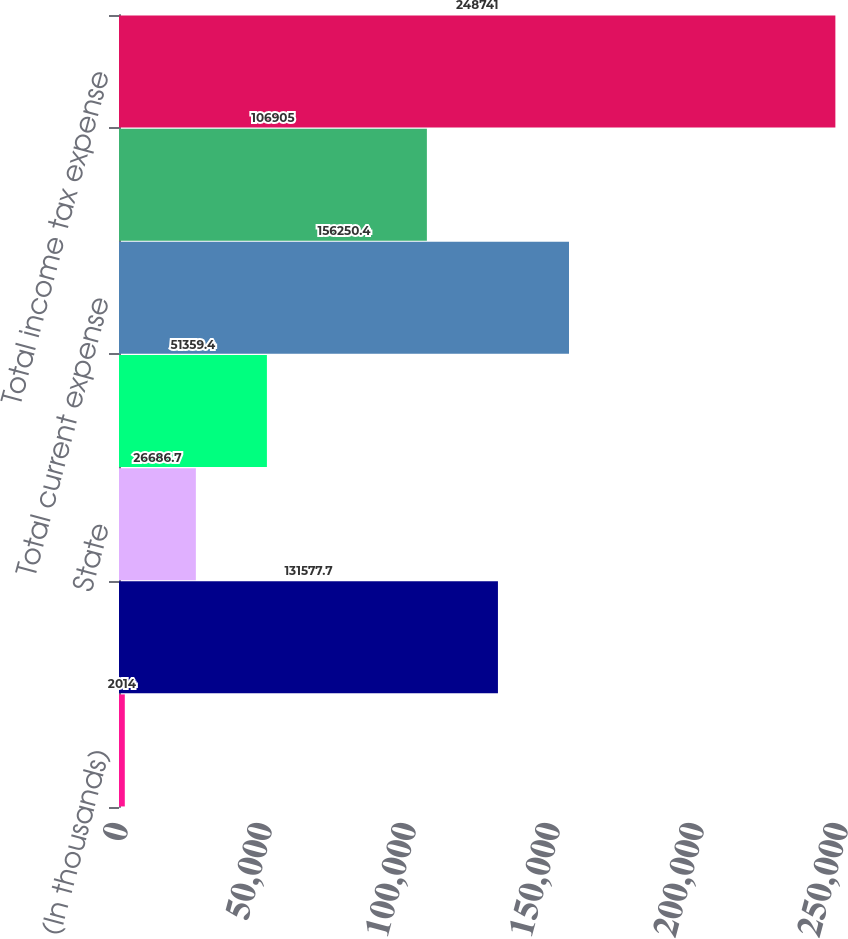<chart> <loc_0><loc_0><loc_500><loc_500><bar_chart><fcel>(In thousands)<fcel>Federal<fcel>State<fcel>Foreign<fcel>Total current expense<fcel>Total deferred expense<fcel>Total income tax expense<nl><fcel>2014<fcel>131578<fcel>26686.7<fcel>51359.4<fcel>156250<fcel>106905<fcel>248741<nl></chart> 